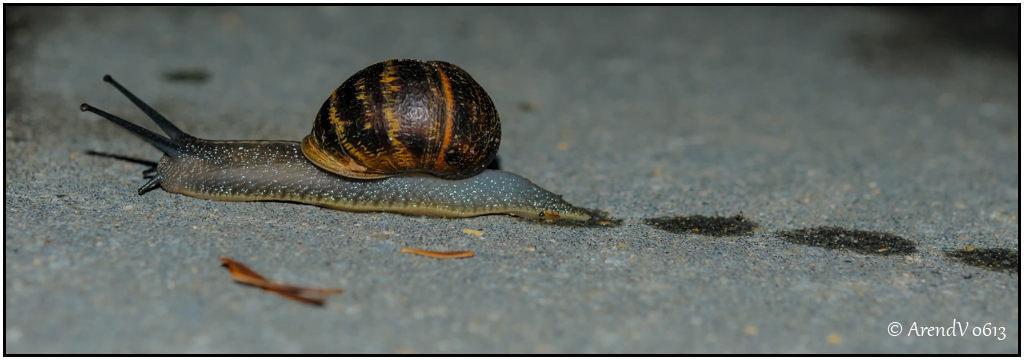Please provide a concise description of this image. This is a zoomed in picture. On the left there is a pond snail on the ground. In the background we can see the ground. At the bottom right corner there is a text on the image. 